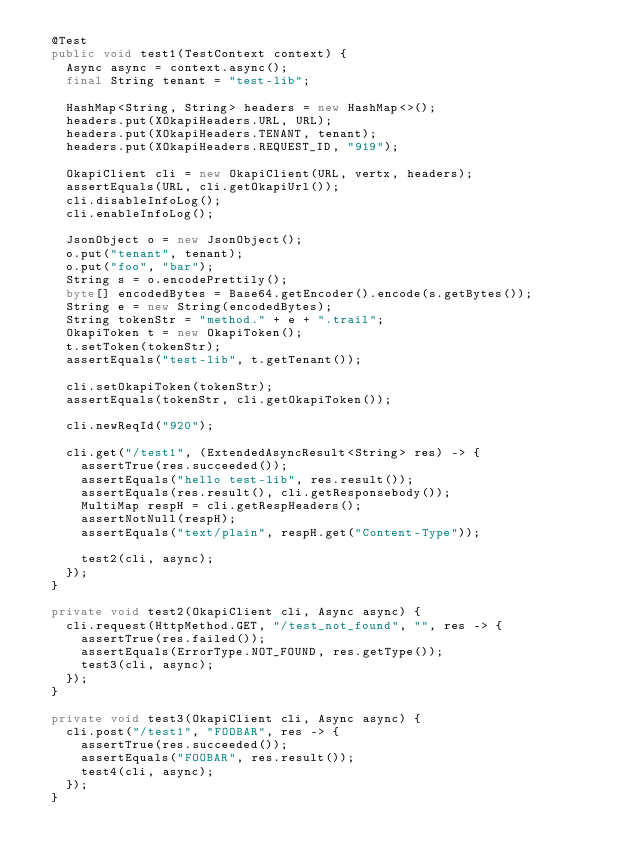<code> <loc_0><loc_0><loc_500><loc_500><_Java_>  @Test
  public void test1(TestContext context) {
    Async async = context.async();
    final String tenant = "test-lib";

    HashMap<String, String> headers = new HashMap<>();
    headers.put(XOkapiHeaders.URL, URL);
    headers.put(XOkapiHeaders.TENANT, tenant);
    headers.put(XOkapiHeaders.REQUEST_ID, "919");

    OkapiClient cli = new OkapiClient(URL, vertx, headers);
    assertEquals(URL, cli.getOkapiUrl());
    cli.disableInfoLog();
    cli.enableInfoLog();

    JsonObject o = new JsonObject();
    o.put("tenant", tenant);
    o.put("foo", "bar");
    String s = o.encodePrettily();
    byte[] encodedBytes = Base64.getEncoder().encode(s.getBytes());
    String e = new String(encodedBytes);
    String tokenStr = "method." + e + ".trail";
    OkapiToken t = new OkapiToken();
    t.setToken(tokenStr);
    assertEquals("test-lib", t.getTenant());

    cli.setOkapiToken(tokenStr);
    assertEquals(tokenStr, cli.getOkapiToken());

    cli.newReqId("920");

    cli.get("/test1", (ExtendedAsyncResult<String> res) -> {
      assertTrue(res.succeeded());
      assertEquals("hello test-lib", res.result());
      assertEquals(res.result(), cli.getResponsebody());
      MultiMap respH = cli.getRespHeaders();
      assertNotNull(respH);
      assertEquals("text/plain", respH.get("Content-Type"));

      test2(cli, async);
    });
  }

  private void test2(OkapiClient cli, Async async) {
    cli.request(HttpMethod.GET, "/test_not_found", "", res -> {
      assertTrue(res.failed());
      assertEquals(ErrorType.NOT_FOUND, res.getType());
      test3(cli, async);
    });
  }

  private void test3(OkapiClient cli, Async async) {
    cli.post("/test1", "FOOBAR", res -> {
      assertTrue(res.succeeded());
      assertEquals("FOOBAR", res.result());
      test4(cli, async);
    });
  }
</code> 